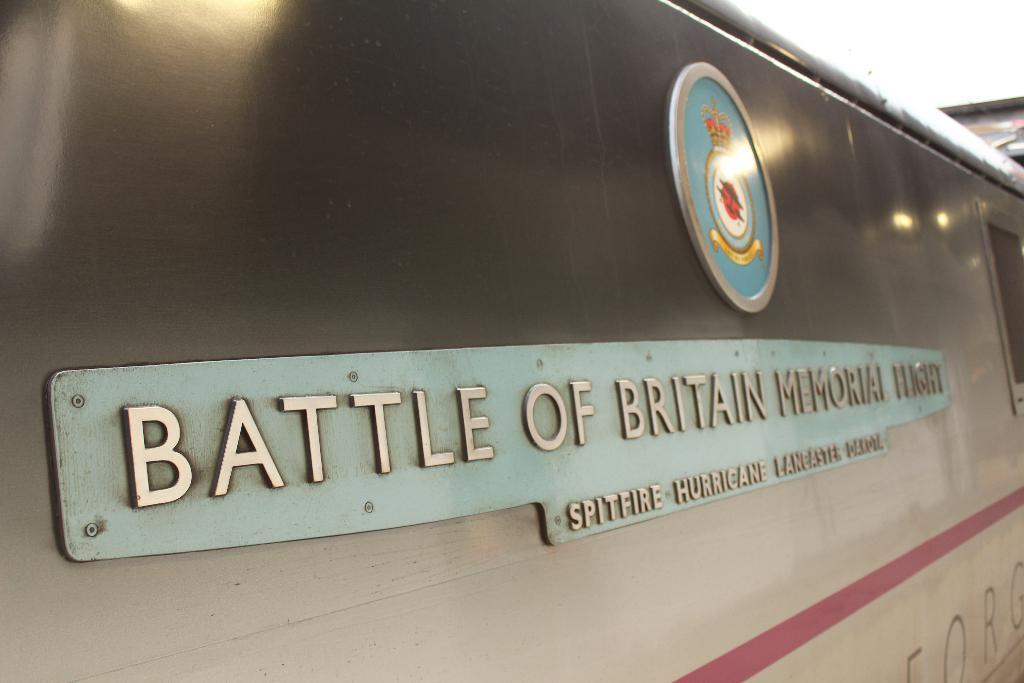What objects are present in the image? There are two boards in the image. Where are the boards located? The boards are on a surface. What can be seen on the boards? There is text written on the boards. What shape is the hand making in the image? There is no hand present in the image; it only features two boards with text on them. 